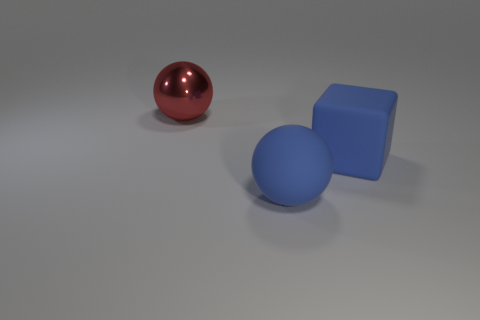Add 1 big gray spheres. How many objects exist? 4 Subtract all cubes. How many objects are left? 2 Subtract all big red balls. Subtract all small brown rubber cubes. How many objects are left? 2 Add 1 large red spheres. How many large red spheres are left? 2 Add 3 large yellow rubber blocks. How many large yellow rubber blocks exist? 3 Subtract 0 purple spheres. How many objects are left? 3 